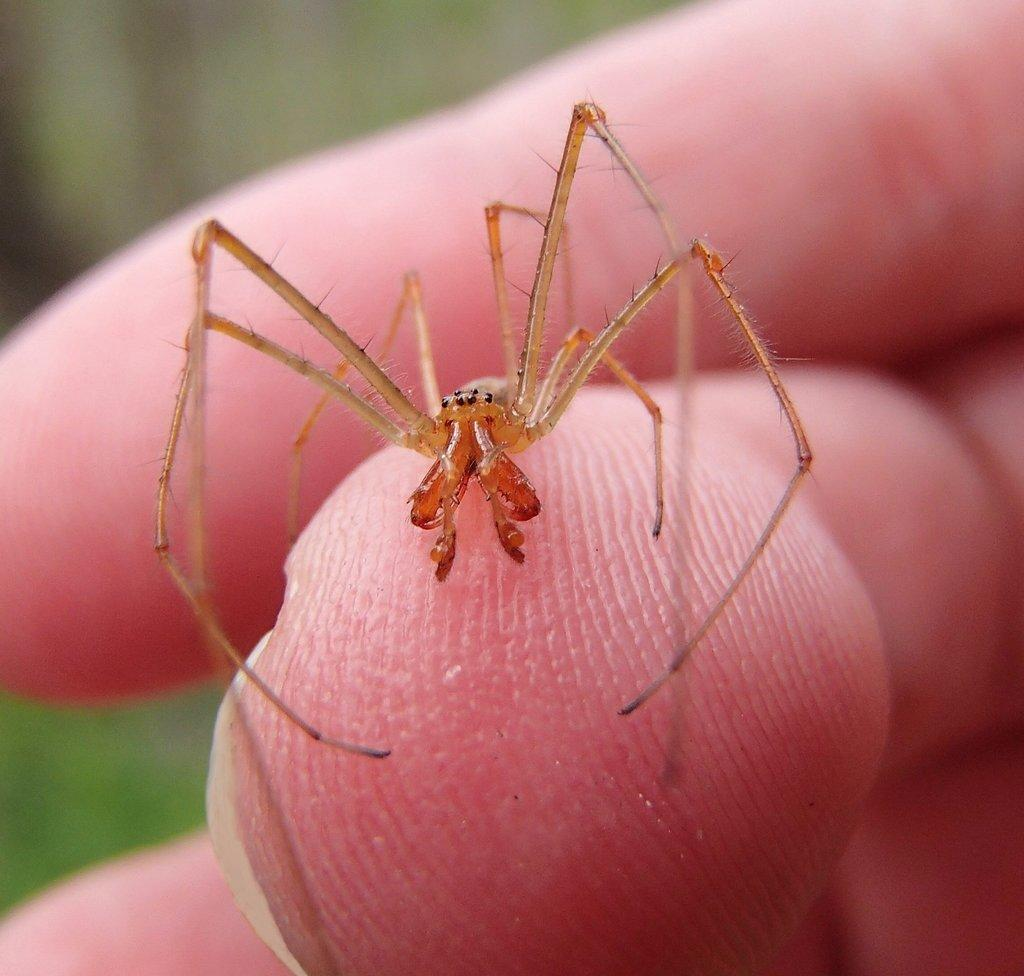What is the main subject of the image? The main subject of the image is a spider. Where is the spider located in the image? The spider is on a person's finger. Can you describe the position of the spider and finger in the image? The spider and finger are in the middle of the image. Is there a stream of water visible in the image? No, there is no stream of water present in the image. What type of bit is the spider using to communicate with the person? The spider is not using any bit to communicate, as spiders do not communicate in this manner. 